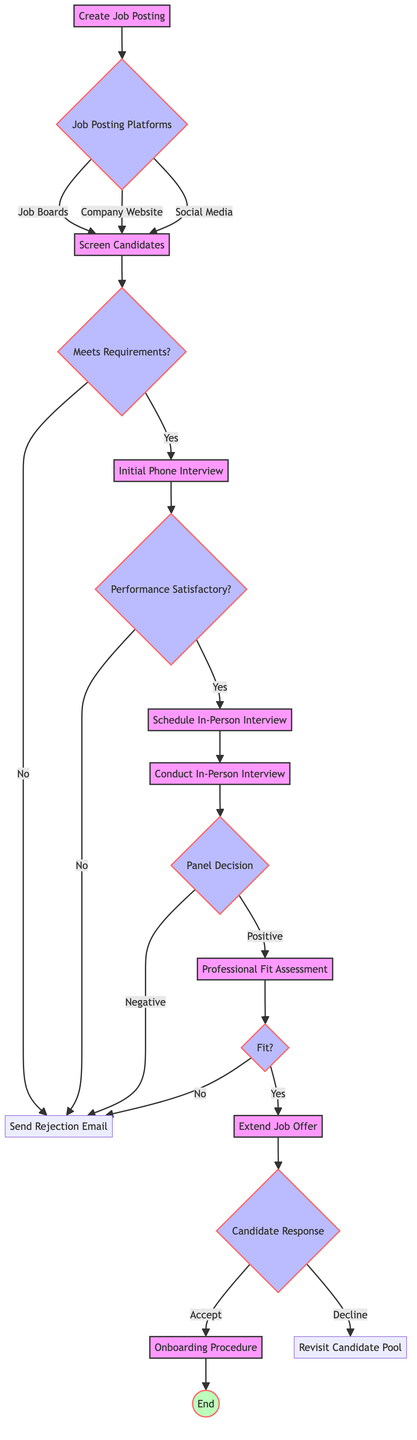What is the first action in the hiring process? The first action is "Create Job Posting," which is indicated at the start of the decision tree.
Answer: Create Job Posting How many job posting platforms are available according to the diagram? There are three options listed under job posting platforms: Job Boards, Company Website, and Social Media, making a total of three.
Answer: 3 If a candidate meets the requirements after screening, what is the next step? If the candidate meets the requirements, the next step is "Initial Phone Interview," as outlined in the diagram under the "Screen Candidates" section.
Answer: Initial Phone Interview What happens if the panel decision is negative after the in-person interview? If the panel decision is negative after the in-person interview, the action is to "Send Rejection Email," as shown in the decision tree.
Answer: Send Rejection Email What is the outcome if the candidate declines the job offer? If the candidate declines the job offer, the next action is to "Revisit Candidate Pool," which is detailed under the "Extend Job Offer" section.
Answer: Revisit Candidate Pool What is the final action in the hiring process workflow? The final action in the hiring process workflow is "End," which follows the "Onboarding Procedure" in the diagram.
Answer: End What is assessed during the Professional Fit Assessment? The Professional Fit Assessment evaluates both skills and cultural fit, as noted in the action description in the diagram.
Answer: Skills and Cultural Fit What action occurs after the initial phone interview if performance is satisfactory? If the performance during the initial phone interview is satisfactory, the next action is to "Schedule In-Person Interview."
Answer: Schedule In-Person Interview How is the candidate's response categorized after extending a job offer? The candidate's response is categorized into two options: "Accept" or "Decline," which lead to different follow-up actions in the process.
Answer: Accept or Decline 